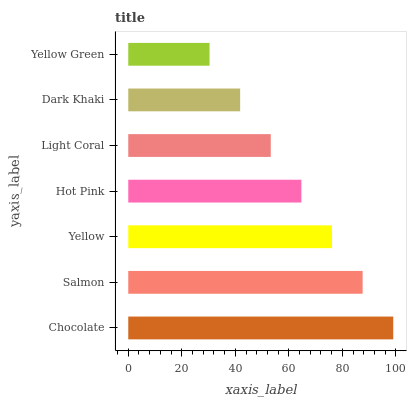Is Yellow Green the minimum?
Answer yes or no. Yes. Is Chocolate the maximum?
Answer yes or no. Yes. Is Salmon the minimum?
Answer yes or no. No. Is Salmon the maximum?
Answer yes or no. No. Is Chocolate greater than Salmon?
Answer yes or no. Yes. Is Salmon less than Chocolate?
Answer yes or no. Yes. Is Salmon greater than Chocolate?
Answer yes or no. No. Is Chocolate less than Salmon?
Answer yes or no. No. Is Hot Pink the high median?
Answer yes or no. Yes. Is Hot Pink the low median?
Answer yes or no. Yes. Is Yellow Green the high median?
Answer yes or no. No. Is Light Coral the low median?
Answer yes or no. No. 